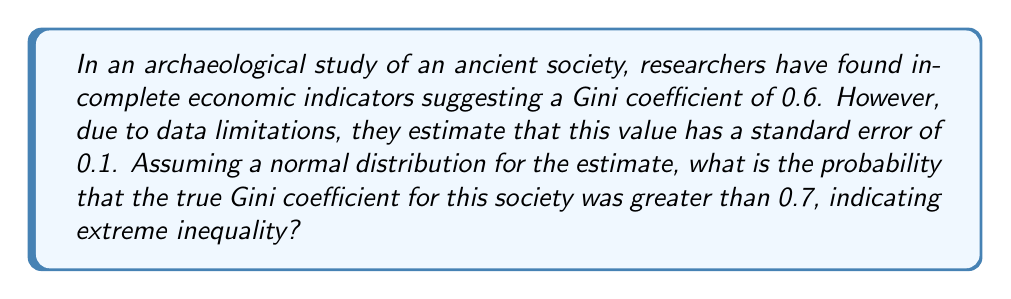Show me your answer to this math problem. To solve this problem, we need to use the properties of the normal distribution and standardize our variable. Let's approach this step-by-step:

1) We are given:
   - Estimated Gini coefficient: $\mu = 0.6$
   - Standard error: $\sigma = 0.1$
   - We want to find P(X > 0.7), where X is the true Gini coefficient

2) To standardize, we use the z-score formula:
   $$z = \frac{x - \mu}{\sigma}$$

3) For x = 0.7, we calculate:
   $$z = \frac{0.7 - 0.6}{0.1} = 1$$

4) Now, we need to find P(Z > 1) where Z follows the standard normal distribution.

5) Using a standard normal table or calculator, we can find that:
   P(Z < 1) ≈ 0.8413

6) Since we want P(Z > 1), and the total probability is 1, we calculate:
   P(Z > 1) = 1 - P(Z < 1) = 1 - 0.8413 = 0.1587

7) Therefore, the probability that the true Gini coefficient is greater than 0.7 is approximately 0.1587 or 15.87%.

This result suggests that while the estimated Gini coefficient is 0.6, there's about a 15.87% chance that the true value exceeds 0.7, indicating potential for extreme inequality in this ancient society.
Answer: 0.1587 